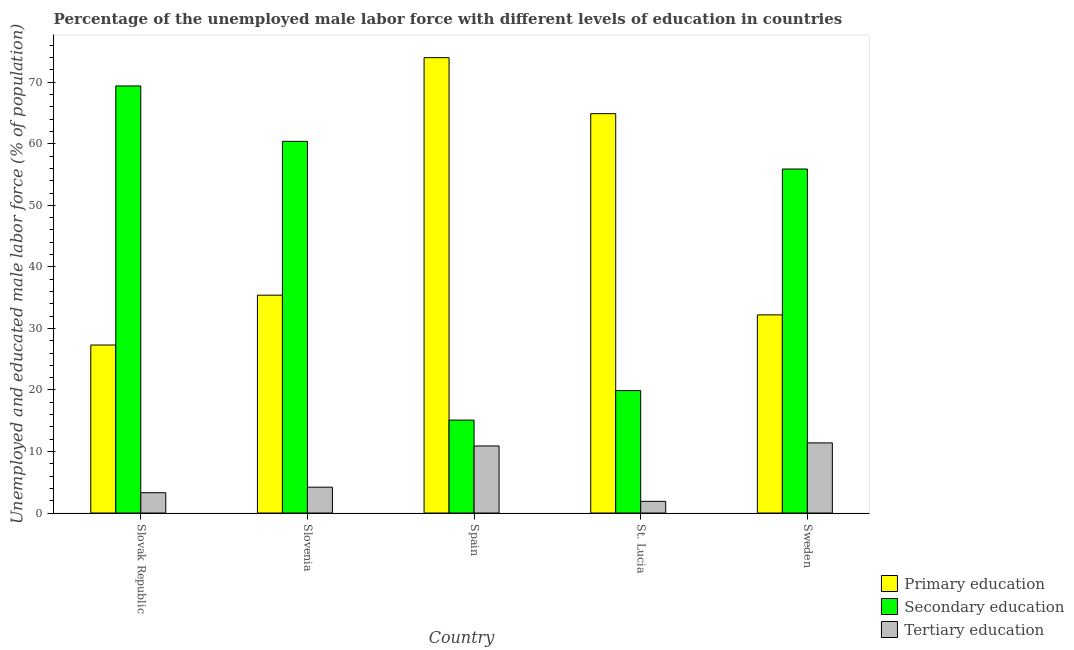How many different coloured bars are there?
Keep it short and to the point. 3. How many groups of bars are there?
Offer a terse response. 5. Are the number of bars per tick equal to the number of legend labels?
Offer a terse response. Yes. How many bars are there on the 2nd tick from the left?
Offer a very short reply. 3. What is the label of the 2nd group of bars from the left?
Your answer should be compact. Slovenia. What is the percentage of male labor force who received tertiary education in Slovenia?
Ensure brevity in your answer.  4.2. Across all countries, what is the maximum percentage of male labor force who received tertiary education?
Make the answer very short. 11.4. Across all countries, what is the minimum percentage of male labor force who received secondary education?
Your answer should be compact. 15.1. In which country was the percentage of male labor force who received secondary education maximum?
Your answer should be very brief. Slovak Republic. What is the total percentage of male labor force who received primary education in the graph?
Your answer should be compact. 233.8. What is the difference between the percentage of male labor force who received tertiary education in Slovenia and that in St. Lucia?
Offer a terse response. 2.3. What is the difference between the percentage of male labor force who received primary education in Slovenia and the percentage of male labor force who received tertiary education in Spain?
Make the answer very short. 24.5. What is the average percentage of male labor force who received tertiary education per country?
Your answer should be compact. 6.34. What is the difference between the percentage of male labor force who received secondary education and percentage of male labor force who received primary education in Sweden?
Make the answer very short. 23.7. In how many countries, is the percentage of male labor force who received secondary education greater than 56 %?
Provide a short and direct response. 2. What is the ratio of the percentage of male labor force who received tertiary education in Slovenia to that in St. Lucia?
Give a very brief answer. 2.21. What is the difference between the highest and the second highest percentage of male labor force who received tertiary education?
Make the answer very short. 0.5. What is the difference between the highest and the lowest percentage of male labor force who received tertiary education?
Provide a succinct answer. 9.5. What does the 2nd bar from the left in Spain represents?
Provide a short and direct response. Secondary education. What does the 1st bar from the right in Slovenia represents?
Give a very brief answer. Tertiary education. Is it the case that in every country, the sum of the percentage of male labor force who received primary education and percentage of male labor force who received secondary education is greater than the percentage of male labor force who received tertiary education?
Provide a succinct answer. Yes. Are all the bars in the graph horizontal?
Your response must be concise. No. Are the values on the major ticks of Y-axis written in scientific E-notation?
Your response must be concise. No. Does the graph contain any zero values?
Keep it short and to the point. No. Does the graph contain grids?
Offer a very short reply. No. Where does the legend appear in the graph?
Give a very brief answer. Bottom right. How are the legend labels stacked?
Provide a short and direct response. Vertical. What is the title of the graph?
Your answer should be very brief. Percentage of the unemployed male labor force with different levels of education in countries. Does "Transport equipments" appear as one of the legend labels in the graph?
Offer a very short reply. No. What is the label or title of the X-axis?
Your answer should be compact. Country. What is the label or title of the Y-axis?
Ensure brevity in your answer.  Unemployed and educated male labor force (% of population). What is the Unemployed and educated male labor force (% of population) in Primary education in Slovak Republic?
Keep it short and to the point. 27.3. What is the Unemployed and educated male labor force (% of population) in Secondary education in Slovak Republic?
Provide a succinct answer. 69.4. What is the Unemployed and educated male labor force (% of population) of Tertiary education in Slovak Republic?
Your answer should be compact. 3.3. What is the Unemployed and educated male labor force (% of population) in Primary education in Slovenia?
Provide a short and direct response. 35.4. What is the Unemployed and educated male labor force (% of population) in Secondary education in Slovenia?
Provide a short and direct response. 60.4. What is the Unemployed and educated male labor force (% of population) of Tertiary education in Slovenia?
Your response must be concise. 4.2. What is the Unemployed and educated male labor force (% of population) of Primary education in Spain?
Provide a succinct answer. 74. What is the Unemployed and educated male labor force (% of population) in Secondary education in Spain?
Your answer should be compact. 15.1. What is the Unemployed and educated male labor force (% of population) in Tertiary education in Spain?
Keep it short and to the point. 10.9. What is the Unemployed and educated male labor force (% of population) in Primary education in St. Lucia?
Your answer should be compact. 64.9. What is the Unemployed and educated male labor force (% of population) of Secondary education in St. Lucia?
Give a very brief answer. 19.9. What is the Unemployed and educated male labor force (% of population) of Tertiary education in St. Lucia?
Provide a short and direct response. 1.9. What is the Unemployed and educated male labor force (% of population) in Primary education in Sweden?
Provide a short and direct response. 32.2. What is the Unemployed and educated male labor force (% of population) of Secondary education in Sweden?
Provide a succinct answer. 55.9. What is the Unemployed and educated male labor force (% of population) of Tertiary education in Sweden?
Your response must be concise. 11.4. Across all countries, what is the maximum Unemployed and educated male labor force (% of population) of Secondary education?
Ensure brevity in your answer.  69.4. Across all countries, what is the maximum Unemployed and educated male labor force (% of population) of Tertiary education?
Your response must be concise. 11.4. Across all countries, what is the minimum Unemployed and educated male labor force (% of population) in Primary education?
Provide a succinct answer. 27.3. Across all countries, what is the minimum Unemployed and educated male labor force (% of population) in Secondary education?
Offer a very short reply. 15.1. Across all countries, what is the minimum Unemployed and educated male labor force (% of population) of Tertiary education?
Offer a very short reply. 1.9. What is the total Unemployed and educated male labor force (% of population) in Primary education in the graph?
Provide a succinct answer. 233.8. What is the total Unemployed and educated male labor force (% of population) in Secondary education in the graph?
Give a very brief answer. 220.7. What is the total Unemployed and educated male labor force (% of population) in Tertiary education in the graph?
Provide a succinct answer. 31.7. What is the difference between the Unemployed and educated male labor force (% of population) of Primary education in Slovak Republic and that in Slovenia?
Your answer should be very brief. -8.1. What is the difference between the Unemployed and educated male labor force (% of population) of Tertiary education in Slovak Republic and that in Slovenia?
Offer a terse response. -0.9. What is the difference between the Unemployed and educated male labor force (% of population) in Primary education in Slovak Republic and that in Spain?
Make the answer very short. -46.7. What is the difference between the Unemployed and educated male labor force (% of population) of Secondary education in Slovak Republic and that in Spain?
Provide a short and direct response. 54.3. What is the difference between the Unemployed and educated male labor force (% of population) in Tertiary education in Slovak Republic and that in Spain?
Ensure brevity in your answer.  -7.6. What is the difference between the Unemployed and educated male labor force (% of population) of Primary education in Slovak Republic and that in St. Lucia?
Offer a very short reply. -37.6. What is the difference between the Unemployed and educated male labor force (% of population) of Secondary education in Slovak Republic and that in St. Lucia?
Make the answer very short. 49.5. What is the difference between the Unemployed and educated male labor force (% of population) in Tertiary education in Slovak Republic and that in Sweden?
Give a very brief answer. -8.1. What is the difference between the Unemployed and educated male labor force (% of population) of Primary education in Slovenia and that in Spain?
Your answer should be very brief. -38.6. What is the difference between the Unemployed and educated male labor force (% of population) in Secondary education in Slovenia and that in Spain?
Give a very brief answer. 45.3. What is the difference between the Unemployed and educated male labor force (% of population) of Tertiary education in Slovenia and that in Spain?
Offer a very short reply. -6.7. What is the difference between the Unemployed and educated male labor force (% of population) in Primary education in Slovenia and that in St. Lucia?
Ensure brevity in your answer.  -29.5. What is the difference between the Unemployed and educated male labor force (% of population) in Secondary education in Slovenia and that in St. Lucia?
Make the answer very short. 40.5. What is the difference between the Unemployed and educated male labor force (% of population) in Tertiary education in Slovenia and that in St. Lucia?
Give a very brief answer. 2.3. What is the difference between the Unemployed and educated male labor force (% of population) in Secondary education in Slovenia and that in Sweden?
Make the answer very short. 4.5. What is the difference between the Unemployed and educated male labor force (% of population) of Tertiary education in Slovenia and that in Sweden?
Keep it short and to the point. -7.2. What is the difference between the Unemployed and educated male labor force (% of population) of Secondary education in Spain and that in St. Lucia?
Offer a very short reply. -4.8. What is the difference between the Unemployed and educated male labor force (% of population) in Tertiary education in Spain and that in St. Lucia?
Ensure brevity in your answer.  9. What is the difference between the Unemployed and educated male labor force (% of population) of Primary education in Spain and that in Sweden?
Your answer should be very brief. 41.8. What is the difference between the Unemployed and educated male labor force (% of population) in Secondary education in Spain and that in Sweden?
Your answer should be very brief. -40.8. What is the difference between the Unemployed and educated male labor force (% of population) in Tertiary education in Spain and that in Sweden?
Your answer should be very brief. -0.5. What is the difference between the Unemployed and educated male labor force (% of population) in Primary education in St. Lucia and that in Sweden?
Your answer should be very brief. 32.7. What is the difference between the Unemployed and educated male labor force (% of population) of Secondary education in St. Lucia and that in Sweden?
Offer a terse response. -36. What is the difference between the Unemployed and educated male labor force (% of population) in Primary education in Slovak Republic and the Unemployed and educated male labor force (% of population) in Secondary education in Slovenia?
Keep it short and to the point. -33.1. What is the difference between the Unemployed and educated male labor force (% of population) in Primary education in Slovak Republic and the Unemployed and educated male labor force (% of population) in Tertiary education in Slovenia?
Your answer should be compact. 23.1. What is the difference between the Unemployed and educated male labor force (% of population) of Secondary education in Slovak Republic and the Unemployed and educated male labor force (% of population) of Tertiary education in Slovenia?
Offer a very short reply. 65.2. What is the difference between the Unemployed and educated male labor force (% of population) in Secondary education in Slovak Republic and the Unemployed and educated male labor force (% of population) in Tertiary education in Spain?
Offer a terse response. 58.5. What is the difference between the Unemployed and educated male labor force (% of population) of Primary education in Slovak Republic and the Unemployed and educated male labor force (% of population) of Tertiary education in St. Lucia?
Give a very brief answer. 25.4. What is the difference between the Unemployed and educated male labor force (% of population) in Secondary education in Slovak Republic and the Unemployed and educated male labor force (% of population) in Tertiary education in St. Lucia?
Your answer should be compact. 67.5. What is the difference between the Unemployed and educated male labor force (% of population) in Primary education in Slovak Republic and the Unemployed and educated male labor force (% of population) in Secondary education in Sweden?
Make the answer very short. -28.6. What is the difference between the Unemployed and educated male labor force (% of population) of Primary education in Slovak Republic and the Unemployed and educated male labor force (% of population) of Tertiary education in Sweden?
Provide a short and direct response. 15.9. What is the difference between the Unemployed and educated male labor force (% of population) of Secondary education in Slovak Republic and the Unemployed and educated male labor force (% of population) of Tertiary education in Sweden?
Your response must be concise. 58. What is the difference between the Unemployed and educated male labor force (% of population) in Primary education in Slovenia and the Unemployed and educated male labor force (% of population) in Secondary education in Spain?
Provide a short and direct response. 20.3. What is the difference between the Unemployed and educated male labor force (% of population) in Primary education in Slovenia and the Unemployed and educated male labor force (% of population) in Tertiary education in Spain?
Your answer should be compact. 24.5. What is the difference between the Unemployed and educated male labor force (% of population) of Secondary education in Slovenia and the Unemployed and educated male labor force (% of population) of Tertiary education in Spain?
Keep it short and to the point. 49.5. What is the difference between the Unemployed and educated male labor force (% of population) of Primary education in Slovenia and the Unemployed and educated male labor force (% of population) of Secondary education in St. Lucia?
Ensure brevity in your answer.  15.5. What is the difference between the Unemployed and educated male labor force (% of population) of Primary education in Slovenia and the Unemployed and educated male labor force (% of population) of Tertiary education in St. Lucia?
Offer a very short reply. 33.5. What is the difference between the Unemployed and educated male labor force (% of population) in Secondary education in Slovenia and the Unemployed and educated male labor force (% of population) in Tertiary education in St. Lucia?
Make the answer very short. 58.5. What is the difference between the Unemployed and educated male labor force (% of population) in Primary education in Slovenia and the Unemployed and educated male labor force (% of population) in Secondary education in Sweden?
Offer a very short reply. -20.5. What is the difference between the Unemployed and educated male labor force (% of population) of Primary education in Spain and the Unemployed and educated male labor force (% of population) of Secondary education in St. Lucia?
Your response must be concise. 54.1. What is the difference between the Unemployed and educated male labor force (% of population) in Primary education in Spain and the Unemployed and educated male labor force (% of population) in Tertiary education in St. Lucia?
Give a very brief answer. 72.1. What is the difference between the Unemployed and educated male labor force (% of population) in Secondary education in Spain and the Unemployed and educated male labor force (% of population) in Tertiary education in St. Lucia?
Your answer should be very brief. 13.2. What is the difference between the Unemployed and educated male labor force (% of population) in Primary education in Spain and the Unemployed and educated male labor force (% of population) in Tertiary education in Sweden?
Offer a terse response. 62.6. What is the difference between the Unemployed and educated male labor force (% of population) in Primary education in St. Lucia and the Unemployed and educated male labor force (% of population) in Tertiary education in Sweden?
Give a very brief answer. 53.5. What is the difference between the Unemployed and educated male labor force (% of population) of Secondary education in St. Lucia and the Unemployed and educated male labor force (% of population) of Tertiary education in Sweden?
Offer a terse response. 8.5. What is the average Unemployed and educated male labor force (% of population) of Primary education per country?
Make the answer very short. 46.76. What is the average Unemployed and educated male labor force (% of population) of Secondary education per country?
Make the answer very short. 44.14. What is the average Unemployed and educated male labor force (% of population) in Tertiary education per country?
Offer a very short reply. 6.34. What is the difference between the Unemployed and educated male labor force (% of population) in Primary education and Unemployed and educated male labor force (% of population) in Secondary education in Slovak Republic?
Your answer should be very brief. -42.1. What is the difference between the Unemployed and educated male labor force (% of population) of Primary education and Unemployed and educated male labor force (% of population) of Tertiary education in Slovak Republic?
Your answer should be very brief. 24. What is the difference between the Unemployed and educated male labor force (% of population) in Secondary education and Unemployed and educated male labor force (% of population) in Tertiary education in Slovak Republic?
Provide a succinct answer. 66.1. What is the difference between the Unemployed and educated male labor force (% of population) of Primary education and Unemployed and educated male labor force (% of population) of Secondary education in Slovenia?
Your answer should be very brief. -25. What is the difference between the Unemployed and educated male labor force (% of population) of Primary education and Unemployed and educated male labor force (% of population) of Tertiary education in Slovenia?
Your response must be concise. 31.2. What is the difference between the Unemployed and educated male labor force (% of population) in Secondary education and Unemployed and educated male labor force (% of population) in Tertiary education in Slovenia?
Your answer should be compact. 56.2. What is the difference between the Unemployed and educated male labor force (% of population) in Primary education and Unemployed and educated male labor force (% of population) in Secondary education in Spain?
Your answer should be compact. 58.9. What is the difference between the Unemployed and educated male labor force (% of population) of Primary education and Unemployed and educated male labor force (% of population) of Tertiary education in Spain?
Offer a very short reply. 63.1. What is the difference between the Unemployed and educated male labor force (% of population) of Secondary education and Unemployed and educated male labor force (% of population) of Tertiary education in Spain?
Provide a succinct answer. 4.2. What is the difference between the Unemployed and educated male labor force (% of population) in Primary education and Unemployed and educated male labor force (% of population) in Secondary education in Sweden?
Offer a terse response. -23.7. What is the difference between the Unemployed and educated male labor force (% of population) in Primary education and Unemployed and educated male labor force (% of population) in Tertiary education in Sweden?
Offer a terse response. 20.8. What is the difference between the Unemployed and educated male labor force (% of population) of Secondary education and Unemployed and educated male labor force (% of population) of Tertiary education in Sweden?
Your answer should be compact. 44.5. What is the ratio of the Unemployed and educated male labor force (% of population) of Primary education in Slovak Republic to that in Slovenia?
Keep it short and to the point. 0.77. What is the ratio of the Unemployed and educated male labor force (% of population) in Secondary education in Slovak Republic to that in Slovenia?
Offer a terse response. 1.15. What is the ratio of the Unemployed and educated male labor force (% of population) of Tertiary education in Slovak Republic to that in Slovenia?
Provide a short and direct response. 0.79. What is the ratio of the Unemployed and educated male labor force (% of population) of Primary education in Slovak Republic to that in Spain?
Your answer should be compact. 0.37. What is the ratio of the Unemployed and educated male labor force (% of population) of Secondary education in Slovak Republic to that in Spain?
Your answer should be compact. 4.6. What is the ratio of the Unemployed and educated male labor force (% of population) in Tertiary education in Slovak Republic to that in Spain?
Give a very brief answer. 0.3. What is the ratio of the Unemployed and educated male labor force (% of population) in Primary education in Slovak Republic to that in St. Lucia?
Offer a terse response. 0.42. What is the ratio of the Unemployed and educated male labor force (% of population) in Secondary education in Slovak Republic to that in St. Lucia?
Give a very brief answer. 3.49. What is the ratio of the Unemployed and educated male labor force (% of population) of Tertiary education in Slovak Republic to that in St. Lucia?
Offer a terse response. 1.74. What is the ratio of the Unemployed and educated male labor force (% of population) in Primary education in Slovak Republic to that in Sweden?
Keep it short and to the point. 0.85. What is the ratio of the Unemployed and educated male labor force (% of population) of Secondary education in Slovak Republic to that in Sweden?
Offer a very short reply. 1.24. What is the ratio of the Unemployed and educated male labor force (% of population) of Tertiary education in Slovak Republic to that in Sweden?
Your response must be concise. 0.29. What is the ratio of the Unemployed and educated male labor force (% of population) in Primary education in Slovenia to that in Spain?
Your response must be concise. 0.48. What is the ratio of the Unemployed and educated male labor force (% of population) of Secondary education in Slovenia to that in Spain?
Your answer should be very brief. 4. What is the ratio of the Unemployed and educated male labor force (% of population) of Tertiary education in Slovenia to that in Spain?
Your answer should be very brief. 0.39. What is the ratio of the Unemployed and educated male labor force (% of population) of Primary education in Slovenia to that in St. Lucia?
Provide a short and direct response. 0.55. What is the ratio of the Unemployed and educated male labor force (% of population) of Secondary education in Slovenia to that in St. Lucia?
Your answer should be compact. 3.04. What is the ratio of the Unemployed and educated male labor force (% of population) in Tertiary education in Slovenia to that in St. Lucia?
Your response must be concise. 2.21. What is the ratio of the Unemployed and educated male labor force (% of population) of Primary education in Slovenia to that in Sweden?
Provide a succinct answer. 1.1. What is the ratio of the Unemployed and educated male labor force (% of population) in Secondary education in Slovenia to that in Sweden?
Provide a succinct answer. 1.08. What is the ratio of the Unemployed and educated male labor force (% of population) in Tertiary education in Slovenia to that in Sweden?
Your answer should be very brief. 0.37. What is the ratio of the Unemployed and educated male labor force (% of population) in Primary education in Spain to that in St. Lucia?
Offer a terse response. 1.14. What is the ratio of the Unemployed and educated male labor force (% of population) of Secondary education in Spain to that in St. Lucia?
Give a very brief answer. 0.76. What is the ratio of the Unemployed and educated male labor force (% of population) of Tertiary education in Spain to that in St. Lucia?
Keep it short and to the point. 5.74. What is the ratio of the Unemployed and educated male labor force (% of population) of Primary education in Spain to that in Sweden?
Provide a succinct answer. 2.3. What is the ratio of the Unemployed and educated male labor force (% of population) of Secondary education in Spain to that in Sweden?
Your answer should be very brief. 0.27. What is the ratio of the Unemployed and educated male labor force (% of population) in Tertiary education in Spain to that in Sweden?
Keep it short and to the point. 0.96. What is the ratio of the Unemployed and educated male labor force (% of population) of Primary education in St. Lucia to that in Sweden?
Ensure brevity in your answer.  2.02. What is the ratio of the Unemployed and educated male labor force (% of population) of Secondary education in St. Lucia to that in Sweden?
Provide a short and direct response. 0.36. What is the difference between the highest and the lowest Unemployed and educated male labor force (% of population) of Primary education?
Offer a terse response. 46.7. What is the difference between the highest and the lowest Unemployed and educated male labor force (% of population) in Secondary education?
Make the answer very short. 54.3. 